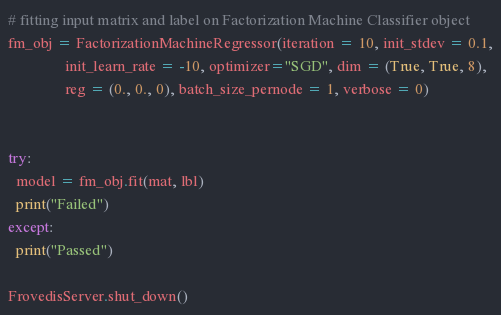<code> <loc_0><loc_0><loc_500><loc_500><_Python_># fitting input matrix and label on Factorization Machine Classifier object
fm_obj = FactorizationMachineRegressor(iteration = 10, init_stdev = 0.1,
               init_learn_rate = -10, optimizer="SGD", dim = (True, True, 8),
               reg = (0., 0., 0), batch_size_pernode = 1, verbose = 0)


try:
  model = fm_obj.fit(mat, lbl)
  print("Failed")
except:
  print("Passed")

FrovedisServer.shut_down()
</code> 